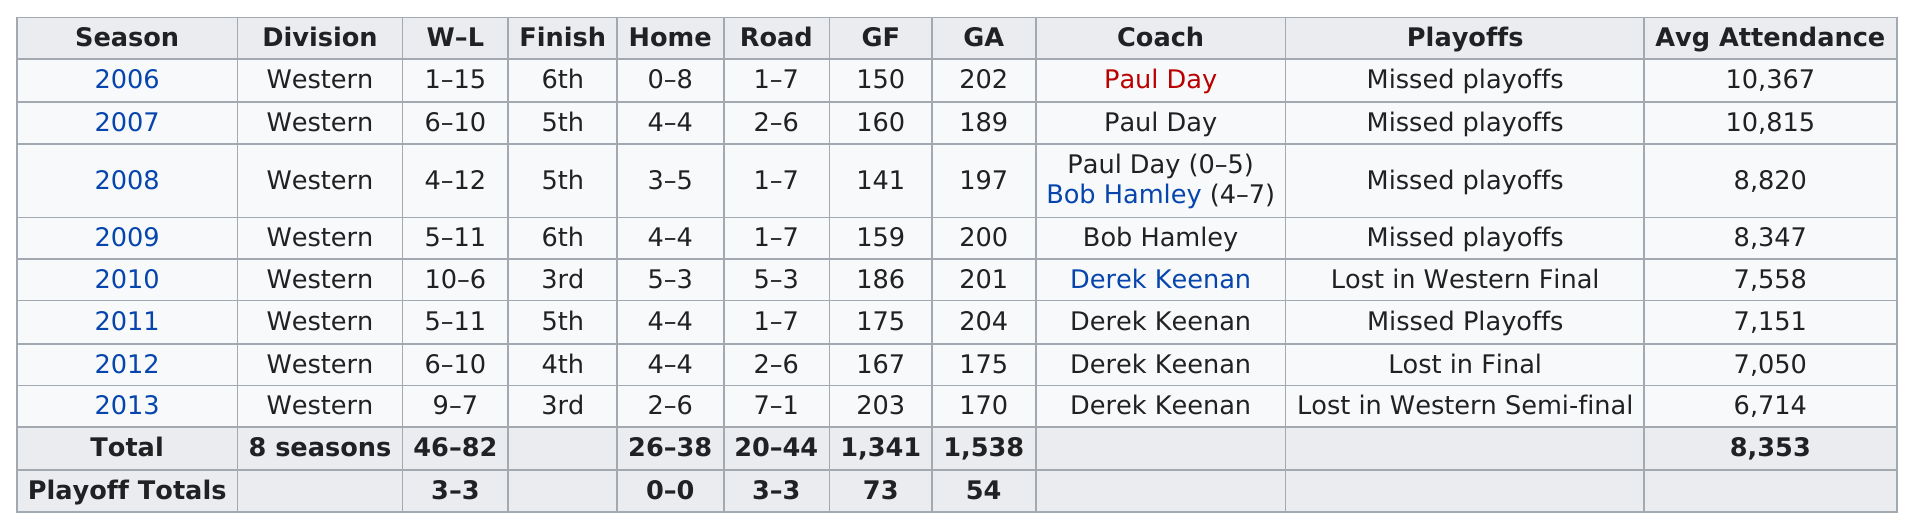Draw attention to some important aspects in this diagram. The question asks for the season that held the most wins. Specifically, the inquiry is directed towards the year 2010. In the year 2010, the Edmonton Rush achieved their most successful season. The team finished above .500 in two seasons, with a winning percentage of more than 50% In 2011, the Rush allowed the most goals. In 2012, the team had 6 wins and 10 losses, and in the previous year, which was 2007, they also had the same record. 